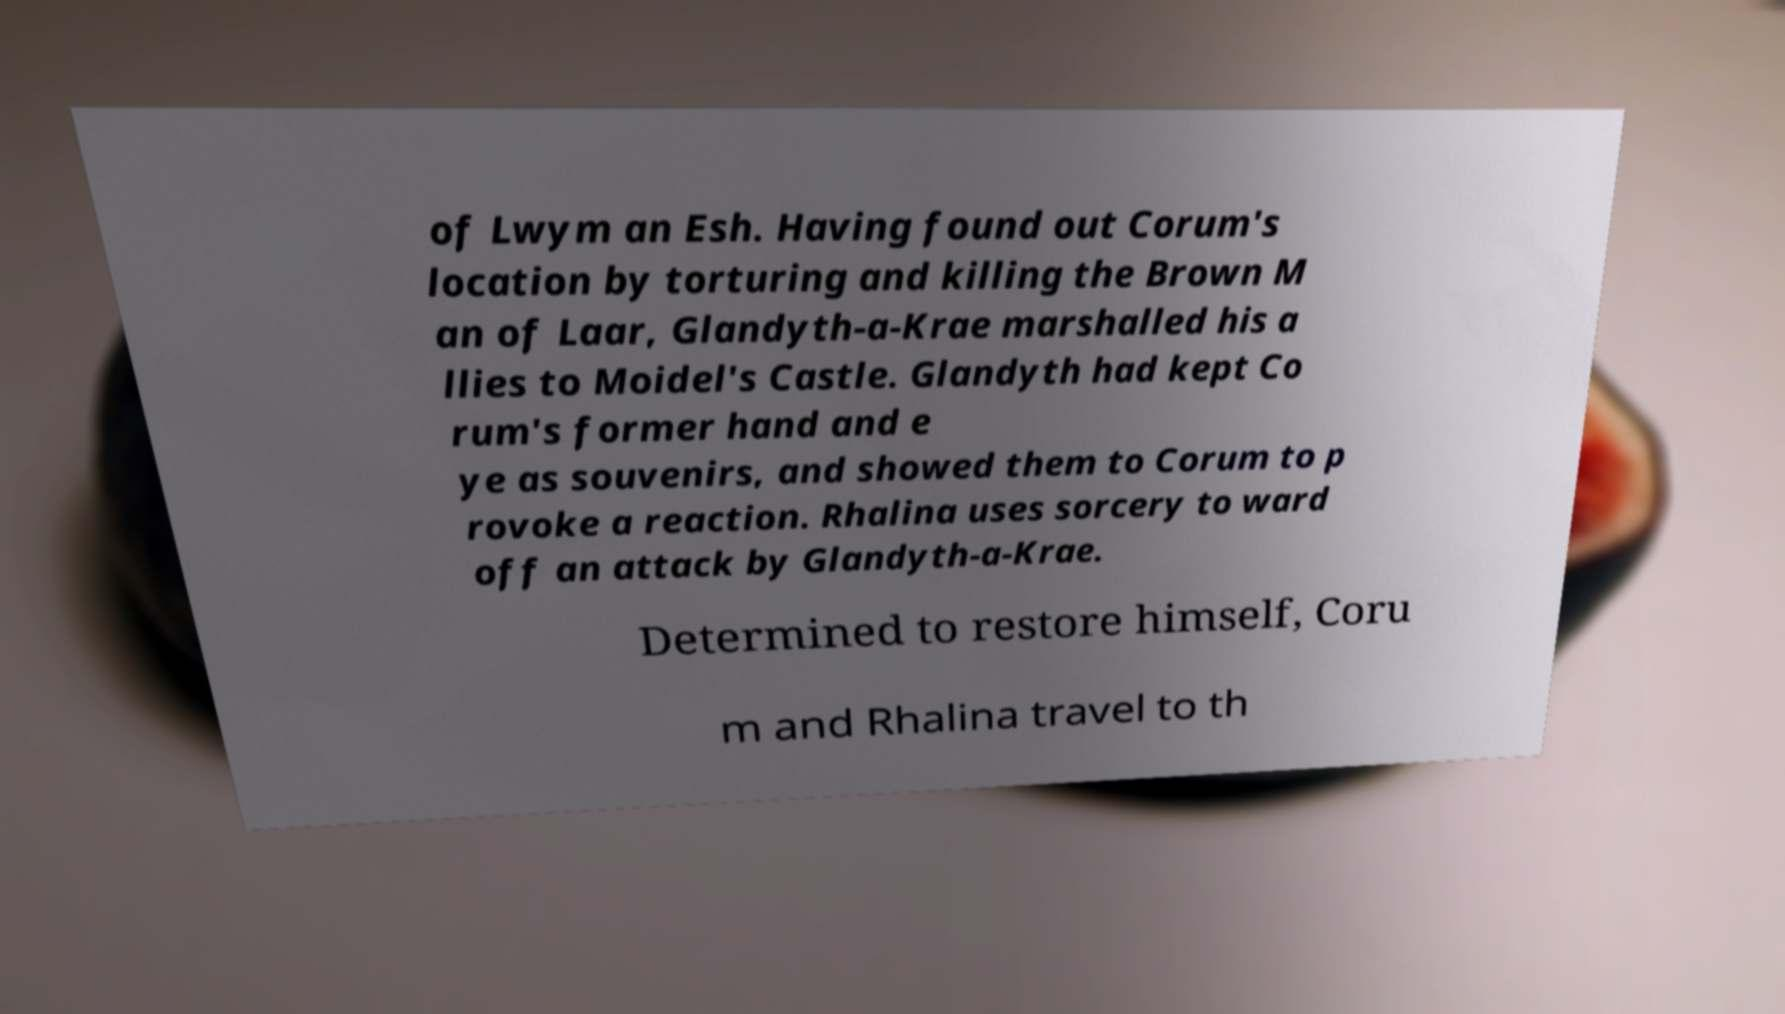Please identify and transcribe the text found in this image. of Lwym an Esh. Having found out Corum's location by torturing and killing the Brown M an of Laar, Glandyth-a-Krae marshalled his a llies to Moidel's Castle. Glandyth had kept Co rum's former hand and e ye as souvenirs, and showed them to Corum to p rovoke a reaction. Rhalina uses sorcery to ward off an attack by Glandyth-a-Krae. Determined to restore himself, Coru m and Rhalina travel to th 